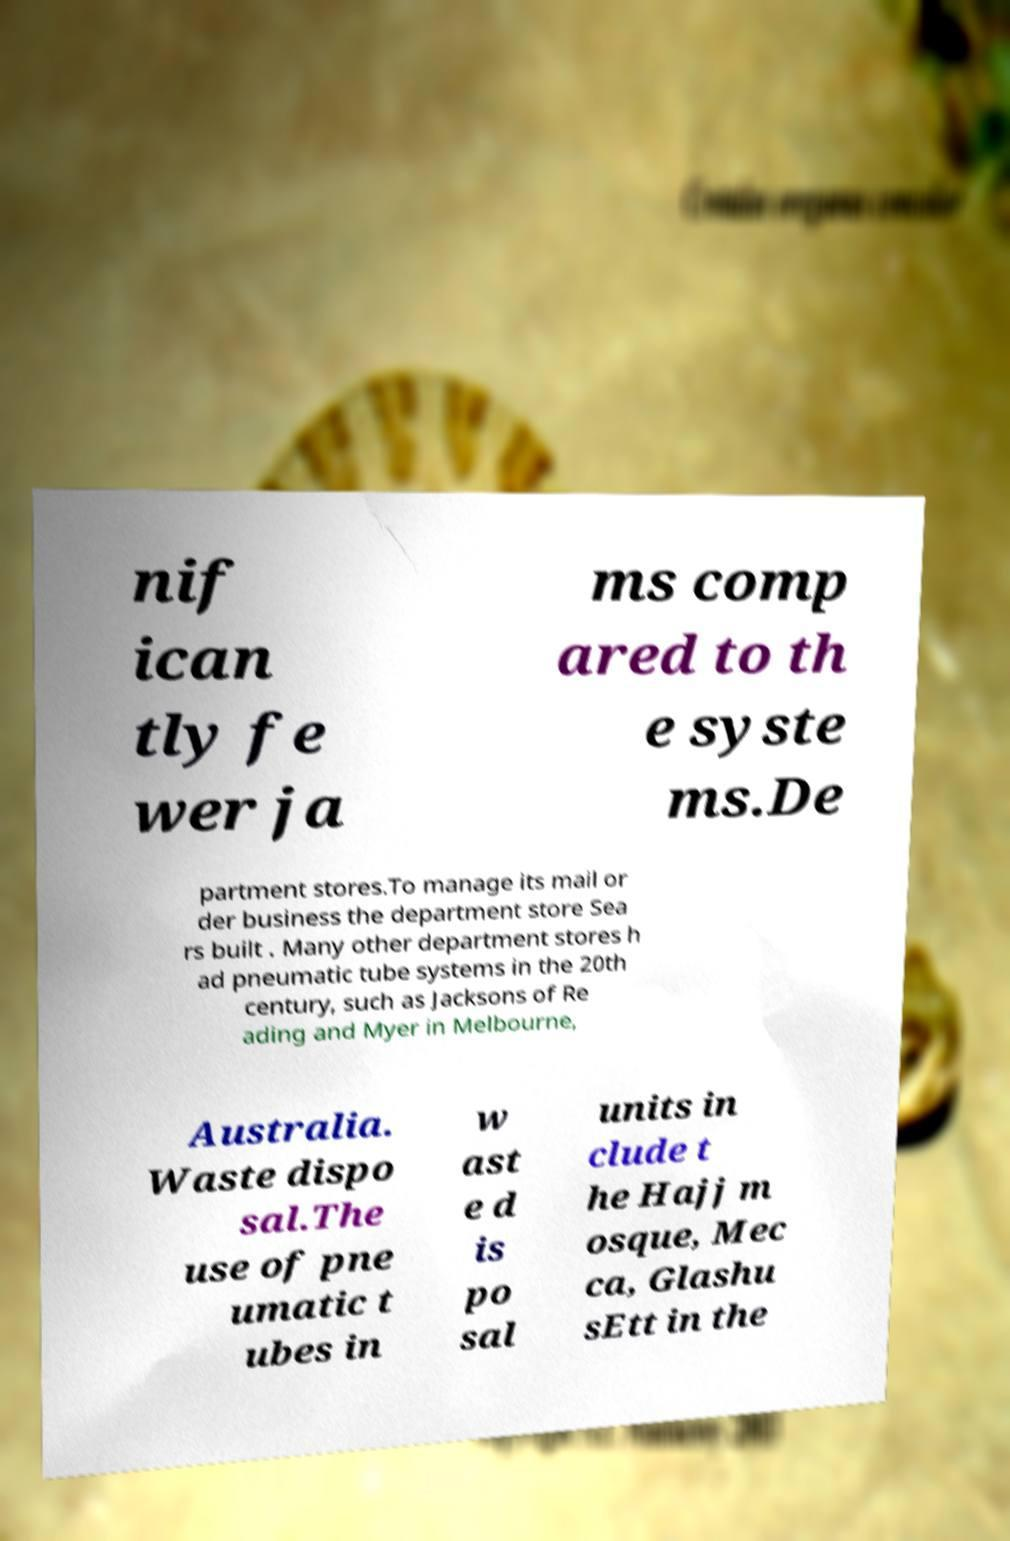Can you accurately transcribe the text from the provided image for me? nif ican tly fe wer ja ms comp ared to th e syste ms.De partment stores.To manage its mail or der business the department store Sea rs built . Many other department stores h ad pneumatic tube systems in the 20th century, such as Jacksons of Re ading and Myer in Melbourne, Australia. Waste dispo sal.The use of pne umatic t ubes in w ast e d is po sal units in clude t he Hajj m osque, Mec ca, Glashu sEtt in the 